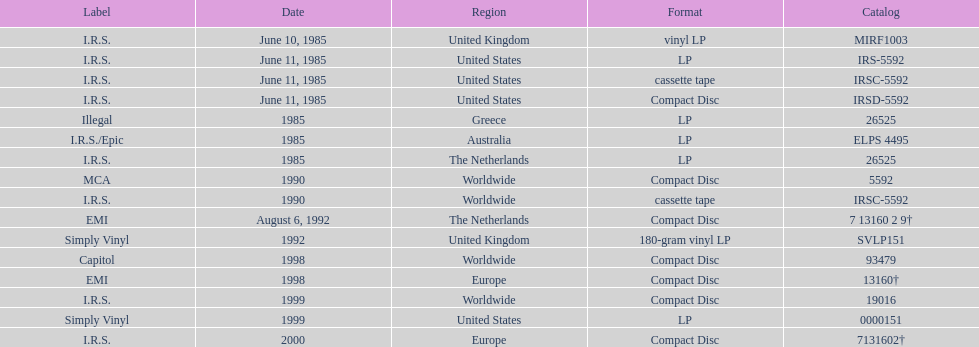How many times was the album released? 13. 